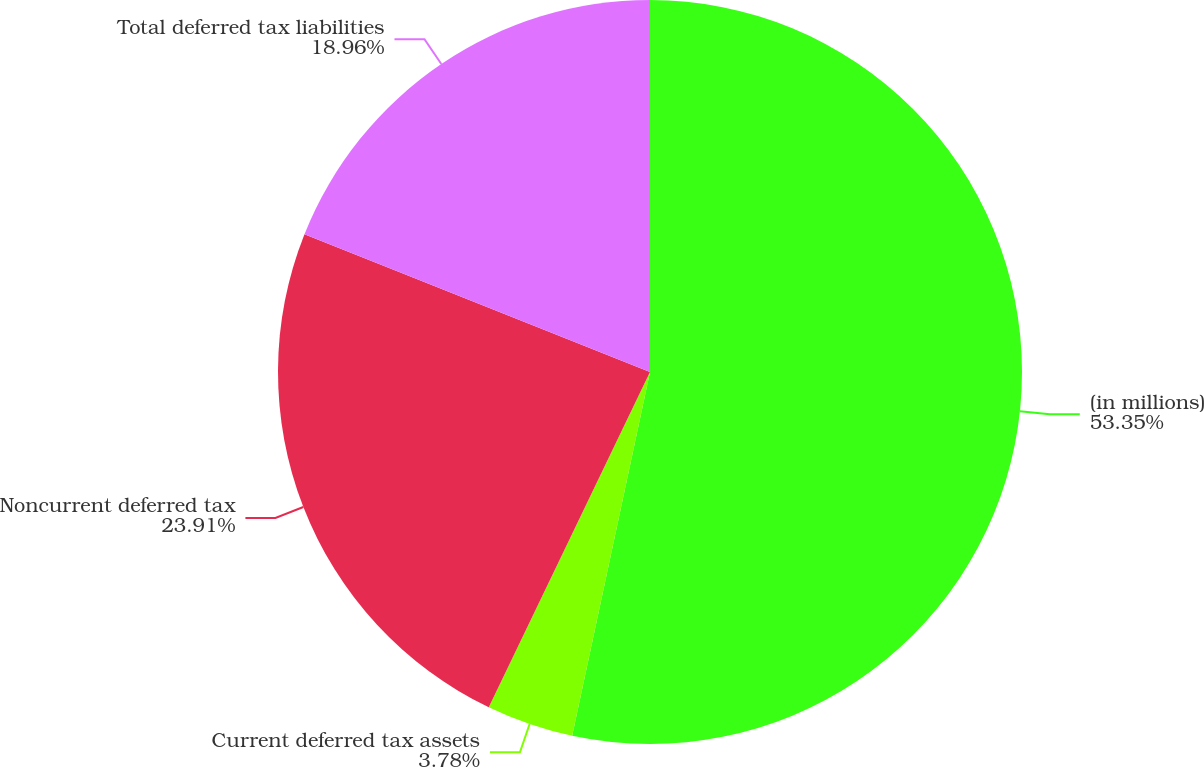Convert chart to OTSL. <chart><loc_0><loc_0><loc_500><loc_500><pie_chart><fcel>(in millions)<fcel>Current deferred tax assets<fcel>Noncurrent deferred tax<fcel>Total deferred tax liabilities<nl><fcel>53.36%<fcel>3.78%<fcel>23.91%<fcel>18.96%<nl></chart> 